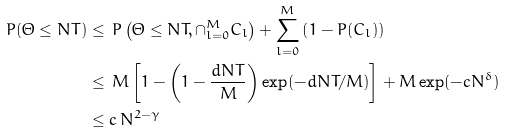<formula> <loc_0><loc_0><loc_500><loc_500>P ( \Theta \leq N T ) & \leq \, P \left ( \Theta \leq N T , \cap _ { l = 0 } ^ { M } C _ { l } \right ) + \sum _ { l = 0 } ^ { M } \left ( 1 - P ( C _ { l } ) \right ) \\ & \leq \, M \left [ 1 - \left ( 1 - \frac { d N T } { M } \right ) \exp ( - d N T / M ) \right ] + M \exp ( - c N ^ { \delta } ) \\ & \leq c \, N ^ { 2 - \gamma }</formula> 